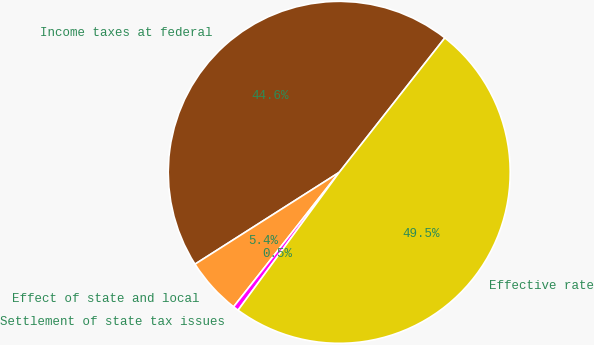Convert chart to OTSL. <chart><loc_0><loc_0><loc_500><loc_500><pie_chart><fcel>Income taxes at federal<fcel>Effect of state and local<fcel>Settlement of state tax issues<fcel>Effective rate<nl><fcel>44.62%<fcel>5.38%<fcel>0.52%<fcel>49.48%<nl></chart> 